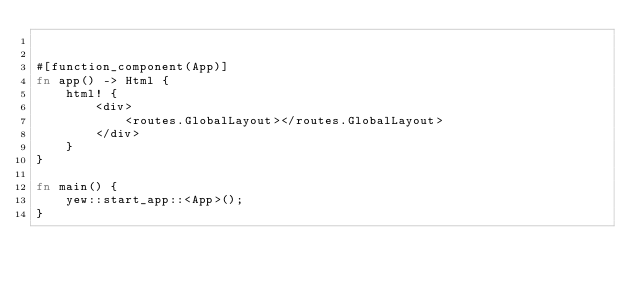Convert code to text. <code><loc_0><loc_0><loc_500><loc_500><_Rust_>

#[function_component(App)]
fn app() -> Html {
    html! {
        <div>
            <routes.GlobalLayout></routes.GlobalLayout>
        </div>
    }
}

fn main() {
    yew::start_app::<App>();
}</code> 